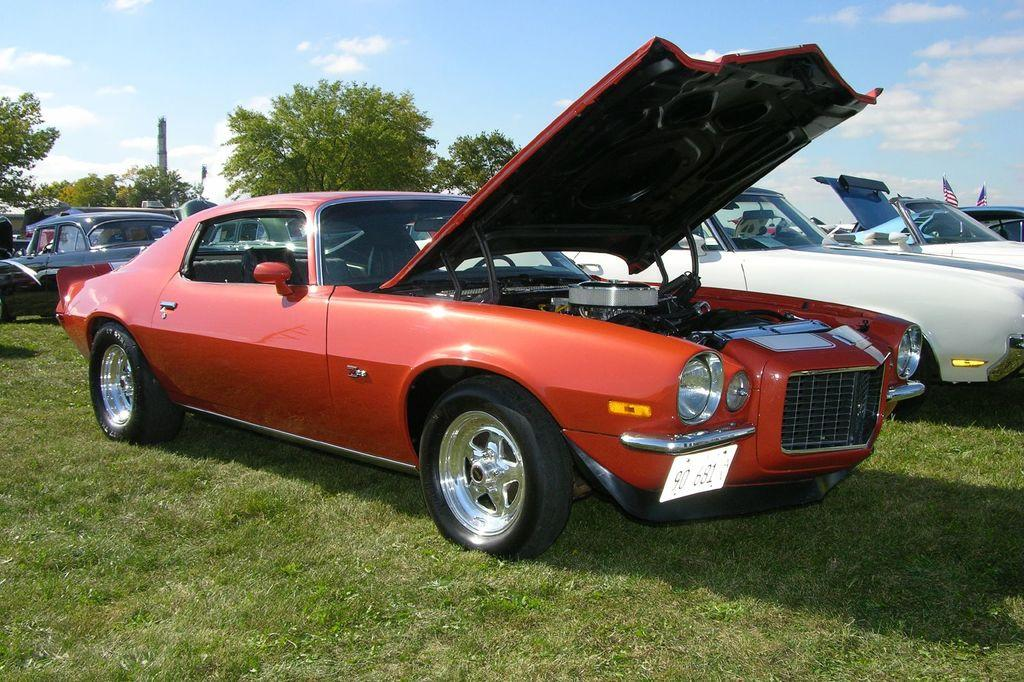What type of vehicles can be seen in the image? There are cars in the image. What type of vegetation is present in the image? There is grass in the image. What can be seen in the background towards the left? There are trees in the background towards the left. What can be seen in the background towards the right? There are flags in the background towards the right. How would you describe the weather in the image? The sky is sunny in the image. What type of parcel is being delivered by the string attached to the pan in the image? There is no parcel, string, or pan present in the image. 